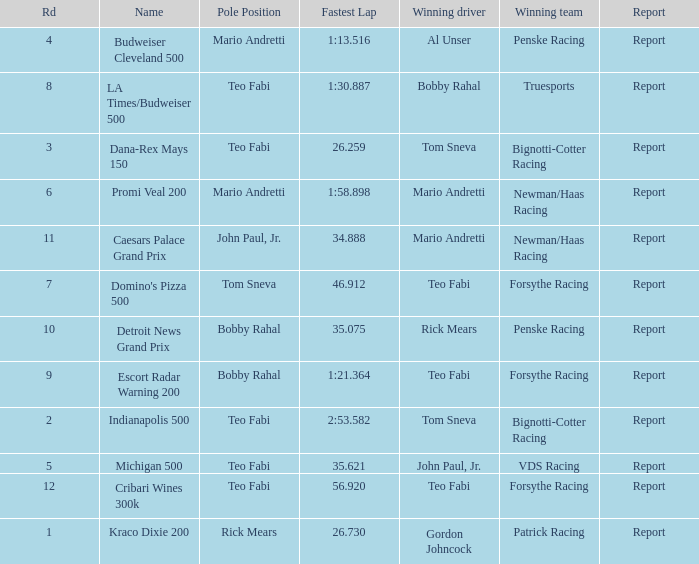How many reports are there in the race that Forsythe Racing won and Teo Fabi had the pole position in? 1.0. 